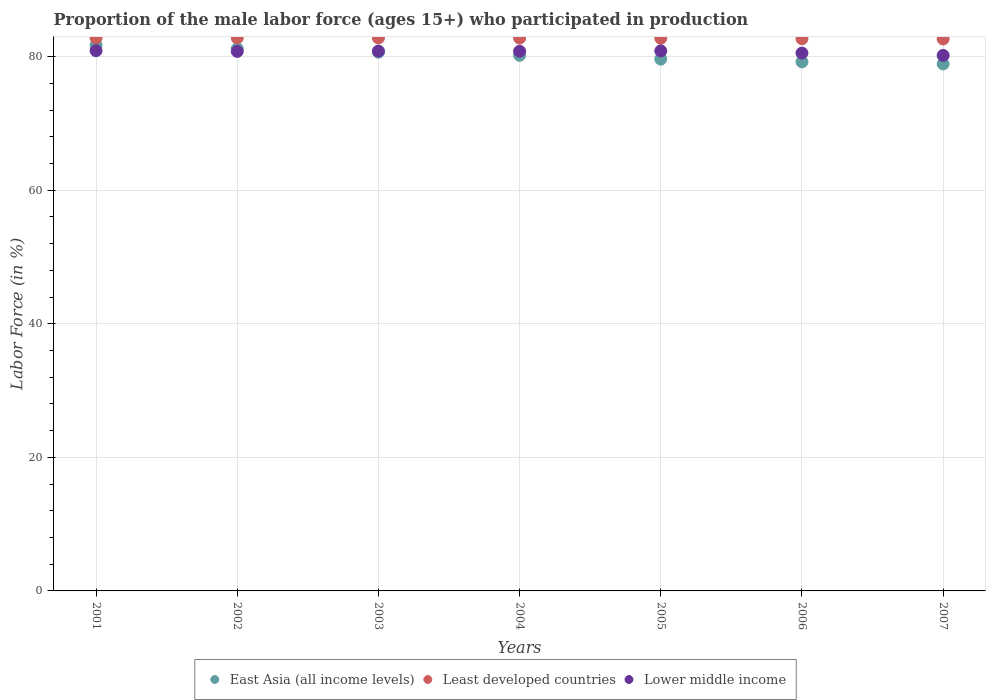Is the number of dotlines equal to the number of legend labels?
Your answer should be very brief. Yes. What is the proportion of the male labor force who participated in production in Lower middle income in 2007?
Your answer should be compact. 80.19. Across all years, what is the maximum proportion of the male labor force who participated in production in East Asia (all income levels)?
Your response must be concise. 81.72. Across all years, what is the minimum proportion of the male labor force who participated in production in Least developed countries?
Provide a succinct answer. 82.65. What is the total proportion of the male labor force who participated in production in East Asia (all income levels) in the graph?
Your answer should be very brief. 561.59. What is the difference between the proportion of the male labor force who participated in production in Least developed countries in 2005 and that in 2007?
Offer a terse response. 0.11. What is the difference between the proportion of the male labor force who participated in production in Least developed countries in 2006 and the proportion of the male labor force who participated in production in East Asia (all income levels) in 2001?
Your answer should be very brief. 0.98. What is the average proportion of the male labor force who participated in production in Lower middle income per year?
Provide a succinct answer. 80.71. In the year 2006, what is the difference between the proportion of the male labor force who participated in production in Least developed countries and proportion of the male labor force who participated in production in East Asia (all income levels)?
Provide a succinct answer. 3.47. What is the ratio of the proportion of the male labor force who participated in production in Least developed countries in 2002 to that in 2005?
Offer a terse response. 1. Is the proportion of the male labor force who participated in production in Lower middle income in 2003 less than that in 2005?
Keep it short and to the point. Yes. Is the difference between the proportion of the male labor force who participated in production in Least developed countries in 2003 and 2004 greater than the difference between the proportion of the male labor force who participated in production in East Asia (all income levels) in 2003 and 2004?
Offer a very short reply. No. What is the difference between the highest and the second highest proportion of the male labor force who participated in production in East Asia (all income levels)?
Offer a very short reply. 0.52. What is the difference between the highest and the lowest proportion of the male labor force who participated in production in Lower middle income?
Your answer should be very brief. 0.71. In how many years, is the proportion of the male labor force who participated in production in East Asia (all income levels) greater than the average proportion of the male labor force who participated in production in East Asia (all income levels) taken over all years?
Offer a very short reply. 3. Is it the case that in every year, the sum of the proportion of the male labor force who participated in production in East Asia (all income levels) and proportion of the male labor force who participated in production in Lower middle income  is greater than the proportion of the male labor force who participated in production in Least developed countries?
Your answer should be compact. Yes. Does the proportion of the male labor force who participated in production in Least developed countries monotonically increase over the years?
Offer a terse response. No. Is the proportion of the male labor force who participated in production in East Asia (all income levels) strictly less than the proportion of the male labor force who participated in production in Lower middle income over the years?
Offer a terse response. No. How many dotlines are there?
Keep it short and to the point. 3. Does the graph contain any zero values?
Provide a short and direct response. No. Where does the legend appear in the graph?
Provide a short and direct response. Bottom center. What is the title of the graph?
Provide a succinct answer. Proportion of the male labor force (ages 15+) who participated in production. Does "Portugal" appear as one of the legend labels in the graph?
Make the answer very short. No. What is the label or title of the X-axis?
Your answer should be very brief. Years. What is the label or title of the Y-axis?
Make the answer very short. Labor Force (in %). What is the Labor Force (in %) of East Asia (all income levels) in 2001?
Provide a succinct answer. 81.72. What is the Labor Force (in %) of Least developed countries in 2001?
Provide a short and direct response. 82.81. What is the Labor Force (in %) in Lower middle income in 2001?
Offer a terse response. 80.9. What is the Labor Force (in %) in East Asia (all income levels) in 2002?
Keep it short and to the point. 81.2. What is the Labor Force (in %) of Least developed countries in 2002?
Give a very brief answer. 82.82. What is the Labor Force (in %) of Lower middle income in 2002?
Offer a terse response. 80.79. What is the Labor Force (in %) of East Asia (all income levels) in 2003?
Ensure brevity in your answer.  80.68. What is the Labor Force (in %) of Least developed countries in 2003?
Give a very brief answer. 82.81. What is the Labor Force (in %) of Lower middle income in 2003?
Your answer should be very brief. 80.84. What is the Labor Force (in %) in East Asia (all income levels) in 2004?
Ensure brevity in your answer.  80.21. What is the Labor Force (in %) in Least developed countries in 2004?
Ensure brevity in your answer.  82.79. What is the Labor Force (in %) of Lower middle income in 2004?
Your answer should be compact. 80.82. What is the Labor Force (in %) of East Asia (all income levels) in 2005?
Offer a very short reply. 79.63. What is the Labor Force (in %) of Least developed countries in 2005?
Provide a succinct answer. 82.76. What is the Labor Force (in %) of Lower middle income in 2005?
Make the answer very short. 80.87. What is the Labor Force (in %) in East Asia (all income levels) in 2006?
Your answer should be compact. 79.23. What is the Labor Force (in %) in Least developed countries in 2006?
Provide a succinct answer. 82.7. What is the Labor Force (in %) in Lower middle income in 2006?
Your answer should be very brief. 80.54. What is the Labor Force (in %) of East Asia (all income levels) in 2007?
Provide a short and direct response. 78.92. What is the Labor Force (in %) in Least developed countries in 2007?
Provide a succinct answer. 82.65. What is the Labor Force (in %) of Lower middle income in 2007?
Provide a succinct answer. 80.19. Across all years, what is the maximum Labor Force (in %) of East Asia (all income levels)?
Give a very brief answer. 81.72. Across all years, what is the maximum Labor Force (in %) in Least developed countries?
Make the answer very short. 82.82. Across all years, what is the maximum Labor Force (in %) of Lower middle income?
Your answer should be very brief. 80.9. Across all years, what is the minimum Labor Force (in %) of East Asia (all income levels)?
Keep it short and to the point. 78.92. Across all years, what is the minimum Labor Force (in %) of Least developed countries?
Your answer should be compact. 82.65. Across all years, what is the minimum Labor Force (in %) of Lower middle income?
Your response must be concise. 80.19. What is the total Labor Force (in %) in East Asia (all income levels) in the graph?
Your answer should be very brief. 561.59. What is the total Labor Force (in %) of Least developed countries in the graph?
Offer a terse response. 579.34. What is the total Labor Force (in %) in Lower middle income in the graph?
Give a very brief answer. 564.96. What is the difference between the Labor Force (in %) in East Asia (all income levels) in 2001 and that in 2002?
Provide a short and direct response. 0.52. What is the difference between the Labor Force (in %) of Least developed countries in 2001 and that in 2002?
Provide a short and direct response. -0.01. What is the difference between the Labor Force (in %) in Lower middle income in 2001 and that in 2002?
Offer a terse response. 0.11. What is the difference between the Labor Force (in %) in East Asia (all income levels) in 2001 and that in 2003?
Provide a succinct answer. 1.04. What is the difference between the Labor Force (in %) of Least developed countries in 2001 and that in 2003?
Your answer should be very brief. -0.01. What is the difference between the Labor Force (in %) in Lower middle income in 2001 and that in 2003?
Your answer should be very brief. 0.06. What is the difference between the Labor Force (in %) in East Asia (all income levels) in 2001 and that in 2004?
Ensure brevity in your answer.  1.51. What is the difference between the Labor Force (in %) in Least developed countries in 2001 and that in 2004?
Offer a very short reply. 0.02. What is the difference between the Labor Force (in %) of Lower middle income in 2001 and that in 2004?
Your answer should be very brief. 0.08. What is the difference between the Labor Force (in %) in East Asia (all income levels) in 2001 and that in 2005?
Give a very brief answer. 2.09. What is the difference between the Labor Force (in %) in Least developed countries in 2001 and that in 2005?
Ensure brevity in your answer.  0.05. What is the difference between the Labor Force (in %) of Lower middle income in 2001 and that in 2005?
Provide a short and direct response. 0.03. What is the difference between the Labor Force (in %) of East Asia (all income levels) in 2001 and that in 2006?
Give a very brief answer. 2.49. What is the difference between the Labor Force (in %) in Least developed countries in 2001 and that in 2006?
Ensure brevity in your answer.  0.11. What is the difference between the Labor Force (in %) in Lower middle income in 2001 and that in 2006?
Offer a terse response. 0.36. What is the difference between the Labor Force (in %) of East Asia (all income levels) in 2001 and that in 2007?
Your answer should be very brief. 2.8. What is the difference between the Labor Force (in %) in Least developed countries in 2001 and that in 2007?
Keep it short and to the point. 0.16. What is the difference between the Labor Force (in %) in Lower middle income in 2001 and that in 2007?
Give a very brief answer. 0.71. What is the difference between the Labor Force (in %) of East Asia (all income levels) in 2002 and that in 2003?
Offer a very short reply. 0.52. What is the difference between the Labor Force (in %) of Least developed countries in 2002 and that in 2003?
Give a very brief answer. 0.01. What is the difference between the Labor Force (in %) of Lower middle income in 2002 and that in 2003?
Provide a succinct answer. -0.05. What is the difference between the Labor Force (in %) of East Asia (all income levels) in 2002 and that in 2004?
Your answer should be compact. 0.99. What is the difference between the Labor Force (in %) of Least developed countries in 2002 and that in 2004?
Provide a short and direct response. 0.03. What is the difference between the Labor Force (in %) in Lower middle income in 2002 and that in 2004?
Your answer should be compact. -0.03. What is the difference between the Labor Force (in %) of East Asia (all income levels) in 2002 and that in 2005?
Ensure brevity in your answer.  1.56. What is the difference between the Labor Force (in %) of Least developed countries in 2002 and that in 2005?
Offer a very short reply. 0.06. What is the difference between the Labor Force (in %) of Lower middle income in 2002 and that in 2005?
Your answer should be compact. -0.08. What is the difference between the Labor Force (in %) of East Asia (all income levels) in 2002 and that in 2006?
Your answer should be very brief. 1.97. What is the difference between the Labor Force (in %) in Least developed countries in 2002 and that in 2006?
Give a very brief answer. 0.12. What is the difference between the Labor Force (in %) in Lower middle income in 2002 and that in 2006?
Make the answer very short. 0.25. What is the difference between the Labor Force (in %) of East Asia (all income levels) in 2002 and that in 2007?
Keep it short and to the point. 2.28. What is the difference between the Labor Force (in %) in Least developed countries in 2002 and that in 2007?
Your response must be concise. 0.17. What is the difference between the Labor Force (in %) in Lower middle income in 2002 and that in 2007?
Give a very brief answer. 0.6. What is the difference between the Labor Force (in %) in East Asia (all income levels) in 2003 and that in 2004?
Make the answer very short. 0.47. What is the difference between the Labor Force (in %) in Least developed countries in 2003 and that in 2004?
Keep it short and to the point. 0.03. What is the difference between the Labor Force (in %) of Lower middle income in 2003 and that in 2004?
Offer a terse response. 0.02. What is the difference between the Labor Force (in %) in East Asia (all income levels) in 2003 and that in 2005?
Provide a succinct answer. 1.04. What is the difference between the Labor Force (in %) of Least developed countries in 2003 and that in 2005?
Offer a terse response. 0.06. What is the difference between the Labor Force (in %) of Lower middle income in 2003 and that in 2005?
Your answer should be very brief. -0.03. What is the difference between the Labor Force (in %) in East Asia (all income levels) in 2003 and that in 2006?
Your response must be concise. 1.45. What is the difference between the Labor Force (in %) of Least developed countries in 2003 and that in 2006?
Offer a very short reply. 0.12. What is the difference between the Labor Force (in %) in Lower middle income in 2003 and that in 2006?
Ensure brevity in your answer.  0.3. What is the difference between the Labor Force (in %) of East Asia (all income levels) in 2003 and that in 2007?
Ensure brevity in your answer.  1.76. What is the difference between the Labor Force (in %) of Least developed countries in 2003 and that in 2007?
Provide a short and direct response. 0.16. What is the difference between the Labor Force (in %) of Lower middle income in 2003 and that in 2007?
Your answer should be very brief. 0.65. What is the difference between the Labor Force (in %) of East Asia (all income levels) in 2004 and that in 2005?
Your response must be concise. 0.58. What is the difference between the Labor Force (in %) in Least developed countries in 2004 and that in 2005?
Offer a very short reply. 0.03. What is the difference between the Labor Force (in %) of Lower middle income in 2004 and that in 2005?
Offer a terse response. -0.05. What is the difference between the Labor Force (in %) in East Asia (all income levels) in 2004 and that in 2006?
Give a very brief answer. 0.98. What is the difference between the Labor Force (in %) of Least developed countries in 2004 and that in 2006?
Give a very brief answer. 0.09. What is the difference between the Labor Force (in %) of Lower middle income in 2004 and that in 2006?
Keep it short and to the point. 0.27. What is the difference between the Labor Force (in %) of East Asia (all income levels) in 2004 and that in 2007?
Give a very brief answer. 1.29. What is the difference between the Labor Force (in %) in Least developed countries in 2004 and that in 2007?
Keep it short and to the point. 0.14. What is the difference between the Labor Force (in %) in Lower middle income in 2004 and that in 2007?
Keep it short and to the point. 0.63. What is the difference between the Labor Force (in %) of East Asia (all income levels) in 2005 and that in 2006?
Your answer should be compact. 0.41. What is the difference between the Labor Force (in %) in Least developed countries in 2005 and that in 2006?
Your answer should be very brief. 0.06. What is the difference between the Labor Force (in %) in Lower middle income in 2005 and that in 2006?
Offer a very short reply. 0.33. What is the difference between the Labor Force (in %) of East Asia (all income levels) in 2005 and that in 2007?
Ensure brevity in your answer.  0.71. What is the difference between the Labor Force (in %) of Least developed countries in 2005 and that in 2007?
Your answer should be very brief. 0.11. What is the difference between the Labor Force (in %) of Lower middle income in 2005 and that in 2007?
Offer a terse response. 0.68. What is the difference between the Labor Force (in %) in East Asia (all income levels) in 2006 and that in 2007?
Offer a terse response. 0.31. What is the difference between the Labor Force (in %) in Least developed countries in 2006 and that in 2007?
Keep it short and to the point. 0.05. What is the difference between the Labor Force (in %) of Lower middle income in 2006 and that in 2007?
Offer a very short reply. 0.35. What is the difference between the Labor Force (in %) in East Asia (all income levels) in 2001 and the Labor Force (in %) in Least developed countries in 2002?
Keep it short and to the point. -1.1. What is the difference between the Labor Force (in %) of East Asia (all income levels) in 2001 and the Labor Force (in %) of Lower middle income in 2002?
Your answer should be compact. 0.93. What is the difference between the Labor Force (in %) of Least developed countries in 2001 and the Labor Force (in %) of Lower middle income in 2002?
Keep it short and to the point. 2.02. What is the difference between the Labor Force (in %) in East Asia (all income levels) in 2001 and the Labor Force (in %) in Least developed countries in 2003?
Your answer should be compact. -1.09. What is the difference between the Labor Force (in %) of East Asia (all income levels) in 2001 and the Labor Force (in %) of Lower middle income in 2003?
Your response must be concise. 0.88. What is the difference between the Labor Force (in %) in Least developed countries in 2001 and the Labor Force (in %) in Lower middle income in 2003?
Keep it short and to the point. 1.97. What is the difference between the Labor Force (in %) of East Asia (all income levels) in 2001 and the Labor Force (in %) of Least developed countries in 2004?
Provide a short and direct response. -1.07. What is the difference between the Labor Force (in %) in East Asia (all income levels) in 2001 and the Labor Force (in %) in Lower middle income in 2004?
Offer a terse response. 0.9. What is the difference between the Labor Force (in %) of Least developed countries in 2001 and the Labor Force (in %) of Lower middle income in 2004?
Your response must be concise. 1.99. What is the difference between the Labor Force (in %) of East Asia (all income levels) in 2001 and the Labor Force (in %) of Least developed countries in 2005?
Provide a short and direct response. -1.04. What is the difference between the Labor Force (in %) of East Asia (all income levels) in 2001 and the Labor Force (in %) of Lower middle income in 2005?
Your answer should be compact. 0.85. What is the difference between the Labor Force (in %) in Least developed countries in 2001 and the Labor Force (in %) in Lower middle income in 2005?
Keep it short and to the point. 1.94. What is the difference between the Labor Force (in %) of East Asia (all income levels) in 2001 and the Labor Force (in %) of Least developed countries in 2006?
Your answer should be compact. -0.98. What is the difference between the Labor Force (in %) in East Asia (all income levels) in 2001 and the Labor Force (in %) in Lower middle income in 2006?
Keep it short and to the point. 1.18. What is the difference between the Labor Force (in %) of Least developed countries in 2001 and the Labor Force (in %) of Lower middle income in 2006?
Ensure brevity in your answer.  2.26. What is the difference between the Labor Force (in %) of East Asia (all income levels) in 2001 and the Labor Force (in %) of Least developed countries in 2007?
Keep it short and to the point. -0.93. What is the difference between the Labor Force (in %) in East Asia (all income levels) in 2001 and the Labor Force (in %) in Lower middle income in 2007?
Ensure brevity in your answer.  1.53. What is the difference between the Labor Force (in %) in Least developed countries in 2001 and the Labor Force (in %) in Lower middle income in 2007?
Offer a very short reply. 2.62. What is the difference between the Labor Force (in %) of East Asia (all income levels) in 2002 and the Labor Force (in %) of Least developed countries in 2003?
Your response must be concise. -1.62. What is the difference between the Labor Force (in %) in East Asia (all income levels) in 2002 and the Labor Force (in %) in Lower middle income in 2003?
Your answer should be very brief. 0.36. What is the difference between the Labor Force (in %) of Least developed countries in 2002 and the Labor Force (in %) of Lower middle income in 2003?
Provide a succinct answer. 1.98. What is the difference between the Labor Force (in %) in East Asia (all income levels) in 2002 and the Labor Force (in %) in Least developed countries in 2004?
Give a very brief answer. -1.59. What is the difference between the Labor Force (in %) in East Asia (all income levels) in 2002 and the Labor Force (in %) in Lower middle income in 2004?
Offer a very short reply. 0.38. What is the difference between the Labor Force (in %) in Least developed countries in 2002 and the Labor Force (in %) in Lower middle income in 2004?
Provide a succinct answer. 2. What is the difference between the Labor Force (in %) of East Asia (all income levels) in 2002 and the Labor Force (in %) of Least developed countries in 2005?
Keep it short and to the point. -1.56. What is the difference between the Labor Force (in %) of East Asia (all income levels) in 2002 and the Labor Force (in %) of Lower middle income in 2005?
Keep it short and to the point. 0.33. What is the difference between the Labor Force (in %) in Least developed countries in 2002 and the Labor Force (in %) in Lower middle income in 2005?
Your answer should be compact. 1.95. What is the difference between the Labor Force (in %) of East Asia (all income levels) in 2002 and the Labor Force (in %) of Least developed countries in 2006?
Your answer should be very brief. -1.5. What is the difference between the Labor Force (in %) in East Asia (all income levels) in 2002 and the Labor Force (in %) in Lower middle income in 2006?
Make the answer very short. 0.65. What is the difference between the Labor Force (in %) of Least developed countries in 2002 and the Labor Force (in %) of Lower middle income in 2006?
Make the answer very short. 2.28. What is the difference between the Labor Force (in %) of East Asia (all income levels) in 2002 and the Labor Force (in %) of Least developed countries in 2007?
Your answer should be very brief. -1.45. What is the difference between the Labor Force (in %) in Least developed countries in 2002 and the Labor Force (in %) in Lower middle income in 2007?
Provide a short and direct response. 2.63. What is the difference between the Labor Force (in %) in East Asia (all income levels) in 2003 and the Labor Force (in %) in Least developed countries in 2004?
Make the answer very short. -2.11. What is the difference between the Labor Force (in %) in East Asia (all income levels) in 2003 and the Labor Force (in %) in Lower middle income in 2004?
Your answer should be very brief. -0.14. What is the difference between the Labor Force (in %) of Least developed countries in 2003 and the Labor Force (in %) of Lower middle income in 2004?
Offer a very short reply. 2. What is the difference between the Labor Force (in %) of East Asia (all income levels) in 2003 and the Labor Force (in %) of Least developed countries in 2005?
Give a very brief answer. -2.08. What is the difference between the Labor Force (in %) of East Asia (all income levels) in 2003 and the Labor Force (in %) of Lower middle income in 2005?
Provide a succinct answer. -0.19. What is the difference between the Labor Force (in %) of Least developed countries in 2003 and the Labor Force (in %) of Lower middle income in 2005?
Provide a succinct answer. 1.95. What is the difference between the Labor Force (in %) of East Asia (all income levels) in 2003 and the Labor Force (in %) of Least developed countries in 2006?
Keep it short and to the point. -2.02. What is the difference between the Labor Force (in %) of East Asia (all income levels) in 2003 and the Labor Force (in %) of Lower middle income in 2006?
Your response must be concise. 0.14. What is the difference between the Labor Force (in %) in Least developed countries in 2003 and the Labor Force (in %) in Lower middle income in 2006?
Keep it short and to the point. 2.27. What is the difference between the Labor Force (in %) in East Asia (all income levels) in 2003 and the Labor Force (in %) in Least developed countries in 2007?
Your answer should be compact. -1.97. What is the difference between the Labor Force (in %) in East Asia (all income levels) in 2003 and the Labor Force (in %) in Lower middle income in 2007?
Give a very brief answer. 0.49. What is the difference between the Labor Force (in %) in Least developed countries in 2003 and the Labor Force (in %) in Lower middle income in 2007?
Offer a terse response. 2.62. What is the difference between the Labor Force (in %) in East Asia (all income levels) in 2004 and the Labor Force (in %) in Least developed countries in 2005?
Give a very brief answer. -2.55. What is the difference between the Labor Force (in %) in East Asia (all income levels) in 2004 and the Labor Force (in %) in Lower middle income in 2005?
Keep it short and to the point. -0.66. What is the difference between the Labor Force (in %) in Least developed countries in 2004 and the Labor Force (in %) in Lower middle income in 2005?
Your answer should be compact. 1.92. What is the difference between the Labor Force (in %) in East Asia (all income levels) in 2004 and the Labor Force (in %) in Least developed countries in 2006?
Your answer should be compact. -2.49. What is the difference between the Labor Force (in %) of East Asia (all income levels) in 2004 and the Labor Force (in %) of Lower middle income in 2006?
Make the answer very short. -0.33. What is the difference between the Labor Force (in %) in Least developed countries in 2004 and the Labor Force (in %) in Lower middle income in 2006?
Your answer should be very brief. 2.24. What is the difference between the Labor Force (in %) of East Asia (all income levels) in 2004 and the Labor Force (in %) of Least developed countries in 2007?
Your answer should be very brief. -2.44. What is the difference between the Labor Force (in %) of East Asia (all income levels) in 2004 and the Labor Force (in %) of Lower middle income in 2007?
Your response must be concise. 0.02. What is the difference between the Labor Force (in %) of Least developed countries in 2004 and the Labor Force (in %) of Lower middle income in 2007?
Your answer should be very brief. 2.59. What is the difference between the Labor Force (in %) of East Asia (all income levels) in 2005 and the Labor Force (in %) of Least developed countries in 2006?
Your answer should be very brief. -3.06. What is the difference between the Labor Force (in %) of East Asia (all income levels) in 2005 and the Labor Force (in %) of Lower middle income in 2006?
Offer a very short reply. -0.91. What is the difference between the Labor Force (in %) in Least developed countries in 2005 and the Labor Force (in %) in Lower middle income in 2006?
Give a very brief answer. 2.21. What is the difference between the Labor Force (in %) of East Asia (all income levels) in 2005 and the Labor Force (in %) of Least developed countries in 2007?
Provide a succinct answer. -3.02. What is the difference between the Labor Force (in %) in East Asia (all income levels) in 2005 and the Labor Force (in %) in Lower middle income in 2007?
Provide a short and direct response. -0.56. What is the difference between the Labor Force (in %) in Least developed countries in 2005 and the Labor Force (in %) in Lower middle income in 2007?
Give a very brief answer. 2.56. What is the difference between the Labor Force (in %) of East Asia (all income levels) in 2006 and the Labor Force (in %) of Least developed countries in 2007?
Keep it short and to the point. -3.42. What is the difference between the Labor Force (in %) in East Asia (all income levels) in 2006 and the Labor Force (in %) in Lower middle income in 2007?
Your answer should be very brief. -0.97. What is the difference between the Labor Force (in %) in Least developed countries in 2006 and the Labor Force (in %) in Lower middle income in 2007?
Keep it short and to the point. 2.51. What is the average Labor Force (in %) in East Asia (all income levels) per year?
Make the answer very short. 80.23. What is the average Labor Force (in %) in Least developed countries per year?
Offer a terse response. 82.76. What is the average Labor Force (in %) in Lower middle income per year?
Keep it short and to the point. 80.71. In the year 2001, what is the difference between the Labor Force (in %) in East Asia (all income levels) and Labor Force (in %) in Least developed countries?
Offer a very short reply. -1.09. In the year 2001, what is the difference between the Labor Force (in %) of East Asia (all income levels) and Labor Force (in %) of Lower middle income?
Give a very brief answer. 0.82. In the year 2001, what is the difference between the Labor Force (in %) in Least developed countries and Labor Force (in %) in Lower middle income?
Ensure brevity in your answer.  1.91. In the year 2002, what is the difference between the Labor Force (in %) of East Asia (all income levels) and Labor Force (in %) of Least developed countries?
Provide a succinct answer. -1.62. In the year 2002, what is the difference between the Labor Force (in %) of East Asia (all income levels) and Labor Force (in %) of Lower middle income?
Ensure brevity in your answer.  0.41. In the year 2002, what is the difference between the Labor Force (in %) of Least developed countries and Labor Force (in %) of Lower middle income?
Offer a very short reply. 2.03. In the year 2003, what is the difference between the Labor Force (in %) in East Asia (all income levels) and Labor Force (in %) in Least developed countries?
Ensure brevity in your answer.  -2.14. In the year 2003, what is the difference between the Labor Force (in %) in East Asia (all income levels) and Labor Force (in %) in Lower middle income?
Your response must be concise. -0.16. In the year 2003, what is the difference between the Labor Force (in %) of Least developed countries and Labor Force (in %) of Lower middle income?
Give a very brief answer. 1.97. In the year 2004, what is the difference between the Labor Force (in %) in East Asia (all income levels) and Labor Force (in %) in Least developed countries?
Provide a succinct answer. -2.58. In the year 2004, what is the difference between the Labor Force (in %) of East Asia (all income levels) and Labor Force (in %) of Lower middle income?
Give a very brief answer. -0.61. In the year 2004, what is the difference between the Labor Force (in %) in Least developed countries and Labor Force (in %) in Lower middle income?
Ensure brevity in your answer.  1.97. In the year 2005, what is the difference between the Labor Force (in %) in East Asia (all income levels) and Labor Force (in %) in Least developed countries?
Your answer should be compact. -3.12. In the year 2005, what is the difference between the Labor Force (in %) of East Asia (all income levels) and Labor Force (in %) of Lower middle income?
Keep it short and to the point. -1.23. In the year 2005, what is the difference between the Labor Force (in %) of Least developed countries and Labor Force (in %) of Lower middle income?
Your answer should be compact. 1.89. In the year 2006, what is the difference between the Labor Force (in %) of East Asia (all income levels) and Labor Force (in %) of Least developed countries?
Your answer should be compact. -3.47. In the year 2006, what is the difference between the Labor Force (in %) in East Asia (all income levels) and Labor Force (in %) in Lower middle income?
Make the answer very short. -1.32. In the year 2006, what is the difference between the Labor Force (in %) in Least developed countries and Labor Force (in %) in Lower middle income?
Provide a short and direct response. 2.16. In the year 2007, what is the difference between the Labor Force (in %) of East Asia (all income levels) and Labor Force (in %) of Least developed countries?
Keep it short and to the point. -3.73. In the year 2007, what is the difference between the Labor Force (in %) in East Asia (all income levels) and Labor Force (in %) in Lower middle income?
Provide a short and direct response. -1.27. In the year 2007, what is the difference between the Labor Force (in %) in Least developed countries and Labor Force (in %) in Lower middle income?
Your answer should be compact. 2.46. What is the ratio of the Labor Force (in %) in East Asia (all income levels) in 2001 to that in 2002?
Provide a succinct answer. 1.01. What is the ratio of the Labor Force (in %) of Lower middle income in 2001 to that in 2002?
Your response must be concise. 1. What is the ratio of the Labor Force (in %) in East Asia (all income levels) in 2001 to that in 2003?
Keep it short and to the point. 1.01. What is the ratio of the Labor Force (in %) of East Asia (all income levels) in 2001 to that in 2004?
Make the answer very short. 1.02. What is the ratio of the Labor Force (in %) in Least developed countries in 2001 to that in 2004?
Keep it short and to the point. 1. What is the ratio of the Labor Force (in %) of Lower middle income in 2001 to that in 2004?
Provide a short and direct response. 1. What is the ratio of the Labor Force (in %) in East Asia (all income levels) in 2001 to that in 2005?
Your answer should be compact. 1.03. What is the ratio of the Labor Force (in %) of Least developed countries in 2001 to that in 2005?
Make the answer very short. 1. What is the ratio of the Labor Force (in %) of Lower middle income in 2001 to that in 2005?
Provide a succinct answer. 1. What is the ratio of the Labor Force (in %) of East Asia (all income levels) in 2001 to that in 2006?
Your answer should be compact. 1.03. What is the ratio of the Labor Force (in %) of Least developed countries in 2001 to that in 2006?
Provide a short and direct response. 1. What is the ratio of the Labor Force (in %) in East Asia (all income levels) in 2001 to that in 2007?
Ensure brevity in your answer.  1.04. What is the ratio of the Labor Force (in %) in Lower middle income in 2001 to that in 2007?
Your response must be concise. 1.01. What is the ratio of the Labor Force (in %) of East Asia (all income levels) in 2002 to that in 2003?
Your answer should be compact. 1.01. What is the ratio of the Labor Force (in %) in East Asia (all income levels) in 2002 to that in 2004?
Offer a very short reply. 1.01. What is the ratio of the Labor Force (in %) of East Asia (all income levels) in 2002 to that in 2005?
Offer a terse response. 1.02. What is the ratio of the Labor Force (in %) of East Asia (all income levels) in 2002 to that in 2006?
Give a very brief answer. 1.02. What is the ratio of the Labor Force (in %) of Least developed countries in 2002 to that in 2006?
Give a very brief answer. 1. What is the ratio of the Labor Force (in %) in Lower middle income in 2002 to that in 2006?
Keep it short and to the point. 1. What is the ratio of the Labor Force (in %) of East Asia (all income levels) in 2002 to that in 2007?
Keep it short and to the point. 1.03. What is the ratio of the Labor Force (in %) of Least developed countries in 2002 to that in 2007?
Make the answer very short. 1. What is the ratio of the Labor Force (in %) of Lower middle income in 2002 to that in 2007?
Your answer should be very brief. 1.01. What is the ratio of the Labor Force (in %) of East Asia (all income levels) in 2003 to that in 2004?
Make the answer very short. 1.01. What is the ratio of the Labor Force (in %) of East Asia (all income levels) in 2003 to that in 2005?
Make the answer very short. 1.01. What is the ratio of the Labor Force (in %) of Lower middle income in 2003 to that in 2005?
Your answer should be very brief. 1. What is the ratio of the Labor Force (in %) in East Asia (all income levels) in 2003 to that in 2006?
Offer a terse response. 1.02. What is the ratio of the Labor Force (in %) in East Asia (all income levels) in 2003 to that in 2007?
Your response must be concise. 1.02. What is the ratio of the Labor Force (in %) in Least developed countries in 2003 to that in 2007?
Provide a succinct answer. 1. What is the ratio of the Labor Force (in %) in East Asia (all income levels) in 2004 to that in 2005?
Provide a succinct answer. 1.01. What is the ratio of the Labor Force (in %) in East Asia (all income levels) in 2004 to that in 2006?
Offer a terse response. 1.01. What is the ratio of the Labor Force (in %) of Lower middle income in 2004 to that in 2006?
Offer a terse response. 1. What is the ratio of the Labor Force (in %) of East Asia (all income levels) in 2004 to that in 2007?
Offer a terse response. 1.02. What is the ratio of the Labor Force (in %) of Lower middle income in 2004 to that in 2007?
Ensure brevity in your answer.  1.01. What is the ratio of the Labor Force (in %) in Lower middle income in 2005 to that in 2006?
Your response must be concise. 1. What is the ratio of the Labor Force (in %) in Least developed countries in 2005 to that in 2007?
Provide a short and direct response. 1. What is the ratio of the Labor Force (in %) in Lower middle income in 2005 to that in 2007?
Keep it short and to the point. 1.01. What is the difference between the highest and the second highest Labor Force (in %) of East Asia (all income levels)?
Make the answer very short. 0.52. What is the difference between the highest and the second highest Labor Force (in %) in Least developed countries?
Your answer should be very brief. 0.01. What is the difference between the highest and the second highest Labor Force (in %) in Lower middle income?
Keep it short and to the point. 0.03. What is the difference between the highest and the lowest Labor Force (in %) of East Asia (all income levels)?
Your answer should be compact. 2.8. What is the difference between the highest and the lowest Labor Force (in %) in Least developed countries?
Your answer should be very brief. 0.17. What is the difference between the highest and the lowest Labor Force (in %) of Lower middle income?
Provide a short and direct response. 0.71. 